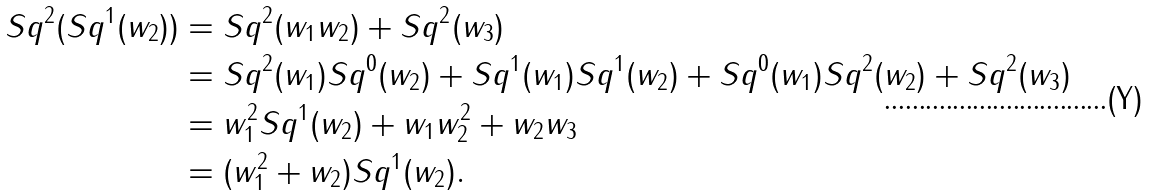<formula> <loc_0><loc_0><loc_500><loc_500>S q ^ { 2 } ( S q ^ { 1 } ( w _ { 2 } ) ) & = S q ^ { 2 } ( w _ { 1 } w _ { 2 } ) + S q ^ { 2 } ( w _ { 3 } ) \\ & = S q ^ { 2 } ( w _ { 1 } ) S q ^ { 0 } ( w _ { 2 } ) + S q ^ { 1 } ( w _ { 1 } ) S q ^ { 1 } ( w _ { 2 } ) + S q ^ { 0 } ( w _ { 1 } ) S q ^ { 2 } ( w _ { 2 } ) + S q ^ { 2 } ( w _ { 3 } ) \\ & = w _ { 1 } ^ { 2 } S q ^ { 1 } ( w _ { 2 } ) + w _ { 1 } w _ { 2 } ^ { 2 } + w _ { 2 } w _ { 3 } \\ & = ( w _ { 1 } ^ { 2 } + w _ { 2 } ) S q ^ { 1 } ( w _ { 2 } ) .</formula> 